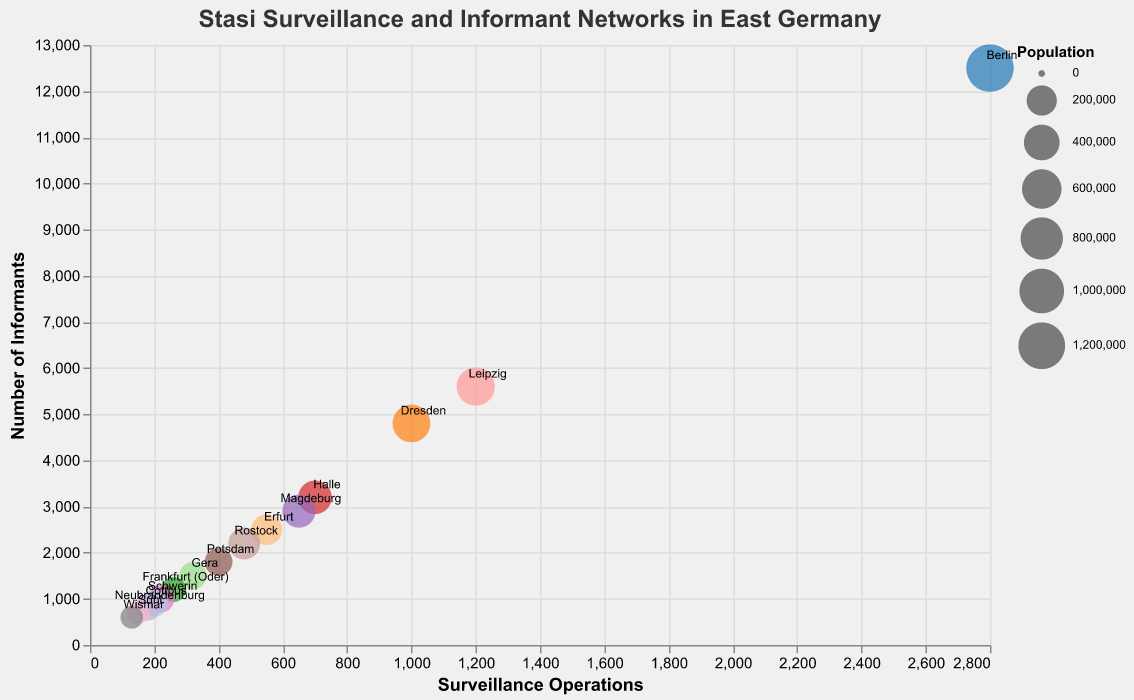How many cities are represented in the figure? Count the distinct cities listed in the plot, ensuring no repeats. There are 15 cities shown: Berlin, Leipzig, Dresden, Halle, Magdeburg, Erfurt, Rostock, Potsdam, Gera, Frankfurt (Oder), Schwerin, Cottbus, Neubrandenburg, Suhl, and Wismar.
Answer: 15 Which city has the most number of surveillance operations? Identify the data point on the x-axis representing the highest surveillance operations count and look at the city labeled next to it. Berlin has the highest number of surveillance operations with 2800.
Answer: Berlin What city has the least number of informants? Find the data point on the y-axis representing the smallest informants count and look at the city labeled next to it. Wismar has the least number of informants with 600.
Answer: Wismar Which city has the largest population? The size of the circles represents population, so locate the largest circle and identify the corresponding city. Berlin has the largest population with 1,275,000.
Answer: Berlin Compare the number of surveillance operations between Halle and Erfurt. Which city has more? Look at the x-axis values for both Halle and Erfurt, and compare them. Halle has 700, while Erfurt has 550, so Halle has more surveillance operations.
Answer: Halle Which city has the highest proportion of informants relative to its population? Calculate the ratio of informants to population for each city and identify the highest ratio. For simplicity, Berlin: 12500/1275000 ≈ 0.0098, Leipzig: 5600/530000 ≈ 0.0106, etc. Wismar has the highest proportion: 600/58000 ≈ 0.0103
Answer: Wismar Is there a visible relationship between population size and the number of informants? Look at the figure to see if larger circles (indicating higher population) tend to be at higher positions on the y-axis (indicating more informants). Very generally, larger population cities like Berlin and Leipzig have higher informant counts, suggesting a positive relationship.
Answer: Yes Among cities with populations less than 150,000, which has the most surveillance operations? Identify all cities with populations under 150,000 and then find the one with the highest x-axis value. Potsdam has the highest with 400 surveillance operations among the cities with populations under 150,000.
Answer: Potsdam What is the ratio of surveillance operations to informants in Dresden? Divide the number of surveillance operations by the number of informants for Dresden (1000/4800). 1000/4800 ≈ 0.2083.
Answer: 0.2083 Compare the total number of informants in Leipzig and Dresden. Which city has more? Look at the y-axis positions for Leipzig and Dresden, noting the informants count for each. Leipzig has 5600 informants, while Dresden has 4800. Therefore, Leipzig has more informants.
Answer: Leipzig 